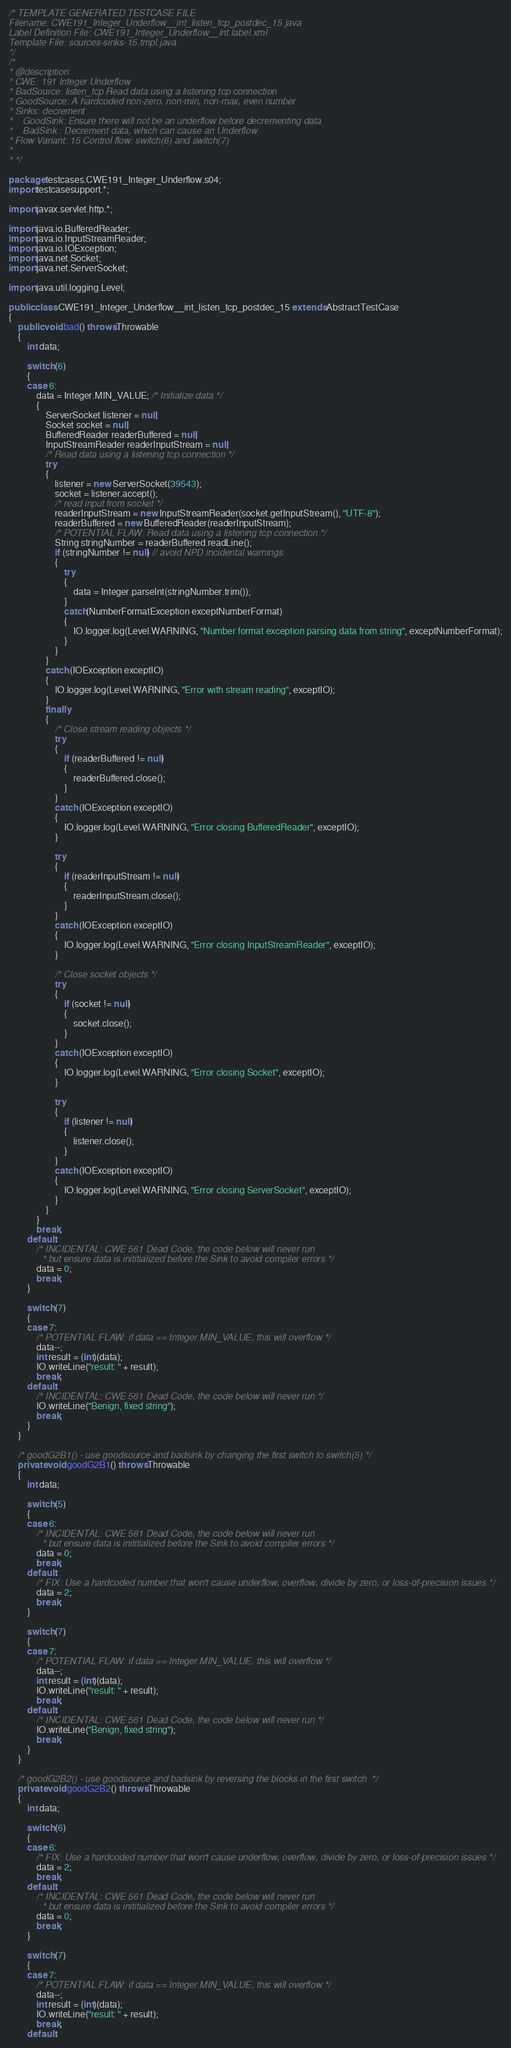<code> <loc_0><loc_0><loc_500><loc_500><_Java_>/* TEMPLATE GENERATED TESTCASE FILE
Filename: CWE191_Integer_Underflow__int_listen_tcp_postdec_15.java
Label Definition File: CWE191_Integer_Underflow__int.label.xml
Template File: sources-sinks-15.tmpl.java
*/
/*
* @description
* CWE: 191 Integer Underflow
* BadSource: listen_tcp Read data using a listening tcp connection
* GoodSource: A hardcoded non-zero, non-min, non-max, even number
* Sinks: decrement
*    GoodSink: Ensure there will not be an underflow before decrementing data
*    BadSink : Decrement data, which can cause an Underflow
* Flow Variant: 15 Control flow: switch(6) and switch(7)
*
* */

package testcases.CWE191_Integer_Underflow.s04;
import testcasesupport.*;

import javax.servlet.http.*;

import java.io.BufferedReader;
import java.io.InputStreamReader;
import java.io.IOException;
import java.net.Socket;
import java.net.ServerSocket;

import java.util.logging.Level;

public class CWE191_Integer_Underflow__int_listen_tcp_postdec_15 extends AbstractTestCase
{
    public void bad() throws Throwable
    {
        int data;

        switch (6)
        {
        case 6:
            data = Integer.MIN_VALUE; /* Initialize data */
            {
                ServerSocket listener = null;
                Socket socket = null;
                BufferedReader readerBuffered = null;
                InputStreamReader readerInputStream = null;
                /* Read data using a listening tcp connection */
                try
                {
                    listener = new ServerSocket(39543);
                    socket = listener.accept();
                    /* read input from socket */
                    readerInputStream = new InputStreamReader(socket.getInputStream(), "UTF-8");
                    readerBuffered = new BufferedReader(readerInputStream);
                    /* POTENTIAL FLAW: Read data using a listening tcp connection */
                    String stringNumber = readerBuffered.readLine();
                    if (stringNumber != null) // avoid NPD incidental warnings
                    {
                        try
                        {
                            data = Integer.parseInt(stringNumber.trim());
                        }
                        catch(NumberFormatException exceptNumberFormat)
                        {
                            IO.logger.log(Level.WARNING, "Number format exception parsing data from string", exceptNumberFormat);
                        }
                    }
                }
                catch (IOException exceptIO)
                {
                    IO.logger.log(Level.WARNING, "Error with stream reading", exceptIO);
                }
                finally
                {
                    /* Close stream reading objects */
                    try
                    {
                        if (readerBuffered != null)
                        {
                            readerBuffered.close();
                        }
                    }
                    catch (IOException exceptIO)
                    {
                        IO.logger.log(Level.WARNING, "Error closing BufferedReader", exceptIO);
                    }

                    try
                    {
                        if (readerInputStream != null)
                        {
                            readerInputStream.close();
                        }
                    }
                    catch (IOException exceptIO)
                    {
                        IO.logger.log(Level.WARNING, "Error closing InputStreamReader", exceptIO);
                    }

                    /* Close socket objects */
                    try
                    {
                        if (socket != null)
                        {
                            socket.close();
                        }
                    }
                    catch (IOException exceptIO)
                    {
                        IO.logger.log(Level.WARNING, "Error closing Socket", exceptIO);
                    }

                    try
                    {
                        if (listener != null)
                        {
                            listener.close();
                        }
                    }
                    catch (IOException exceptIO)
                    {
                        IO.logger.log(Level.WARNING, "Error closing ServerSocket", exceptIO);
                    }
                }
            }
            break;
        default:
            /* INCIDENTAL: CWE 561 Dead Code, the code below will never run
             * but ensure data is inititialized before the Sink to avoid compiler errors */
            data = 0;
            break;
        }

        switch (7)
        {
        case 7:
            /* POTENTIAL FLAW: if data == Integer.MIN_VALUE, this will overflow */
            data--;
            int result = (int)(data);
            IO.writeLine("result: " + result);
            break;
        default:
            /* INCIDENTAL: CWE 561 Dead Code, the code below will never run */
            IO.writeLine("Benign, fixed string");
            break;
        }
    }

    /* goodG2B1() - use goodsource and badsink by changing the first switch to switch(5) */
    private void goodG2B1() throws Throwable
    {
        int data;

        switch (5)
        {
        case 6:
            /* INCIDENTAL: CWE 561 Dead Code, the code below will never run
             * but ensure data is inititialized before the Sink to avoid compiler errors */
            data = 0;
            break;
        default:
            /* FIX: Use a hardcoded number that won't cause underflow, overflow, divide by zero, or loss-of-precision issues */
            data = 2;
            break;
        }

        switch (7)
        {
        case 7:
            /* POTENTIAL FLAW: if data == Integer.MIN_VALUE, this will overflow */
            data--;
            int result = (int)(data);
            IO.writeLine("result: " + result);
            break;
        default:
            /* INCIDENTAL: CWE 561 Dead Code, the code below will never run */
            IO.writeLine("Benign, fixed string");
            break;
        }
    }

    /* goodG2B2() - use goodsource and badsink by reversing the blocks in the first switch  */
    private void goodG2B2() throws Throwable
    {
        int data;

        switch (6)
        {
        case 6:
            /* FIX: Use a hardcoded number that won't cause underflow, overflow, divide by zero, or loss-of-precision issues */
            data = 2;
            break;
        default:
            /* INCIDENTAL: CWE 561 Dead Code, the code below will never run
             * but ensure data is inititialized before the Sink to avoid compiler errors */
            data = 0;
            break;
        }

        switch (7)
        {
        case 7:
            /* POTENTIAL FLAW: if data == Integer.MIN_VALUE, this will overflow */
            data--;
            int result = (int)(data);
            IO.writeLine("result: " + result);
            break;
        default:</code> 